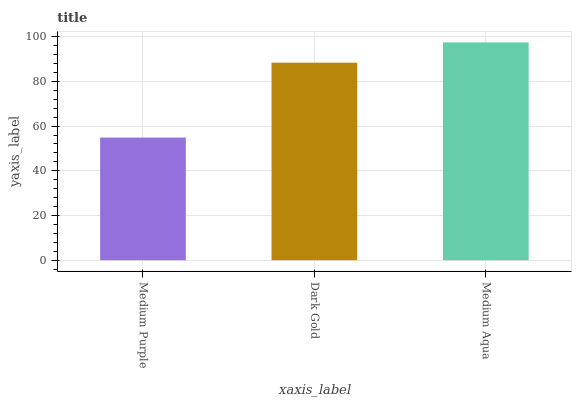Is Medium Purple the minimum?
Answer yes or no. Yes. Is Medium Aqua the maximum?
Answer yes or no. Yes. Is Dark Gold the minimum?
Answer yes or no. No. Is Dark Gold the maximum?
Answer yes or no. No. Is Dark Gold greater than Medium Purple?
Answer yes or no. Yes. Is Medium Purple less than Dark Gold?
Answer yes or no. Yes. Is Medium Purple greater than Dark Gold?
Answer yes or no. No. Is Dark Gold less than Medium Purple?
Answer yes or no. No. Is Dark Gold the high median?
Answer yes or no. Yes. Is Dark Gold the low median?
Answer yes or no. Yes. Is Medium Aqua the high median?
Answer yes or no. No. Is Medium Purple the low median?
Answer yes or no. No. 